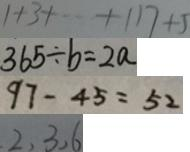Convert formula to latex. <formula><loc_0><loc_0><loc_500><loc_500>1 + 3 + \cdots + 1 1 7 + 5 
 3 6 5 \div b = 2 a 
 9 7 - 4 5 = 5 2 
 2 , 3 , 6</formula> 